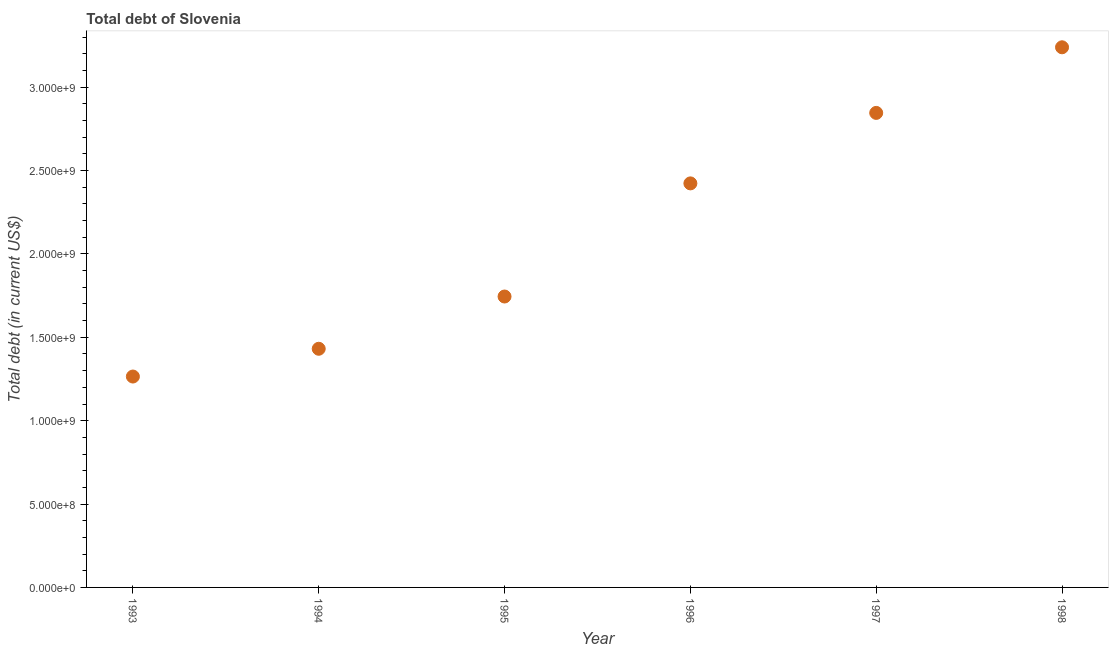What is the total debt in 1995?
Provide a succinct answer. 1.74e+09. Across all years, what is the maximum total debt?
Your response must be concise. 3.24e+09. Across all years, what is the minimum total debt?
Your answer should be compact. 1.26e+09. In which year was the total debt maximum?
Your response must be concise. 1998. In which year was the total debt minimum?
Give a very brief answer. 1993. What is the sum of the total debt?
Keep it short and to the point. 1.29e+1. What is the difference between the total debt in 1997 and 1998?
Make the answer very short. -3.94e+08. What is the average total debt per year?
Ensure brevity in your answer.  2.16e+09. What is the median total debt?
Keep it short and to the point. 2.08e+09. In how many years, is the total debt greater than 1100000000 US$?
Your response must be concise. 6. Do a majority of the years between 1997 and 1995 (inclusive) have total debt greater than 500000000 US$?
Your answer should be compact. No. What is the ratio of the total debt in 1996 to that in 1997?
Your response must be concise. 0.85. Is the total debt in 1993 less than that in 1997?
Your response must be concise. Yes. What is the difference between the highest and the second highest total debt?
Ensure brevity in your answer.  3.94e+08. Is the sum of the total debt in 1993 and 1995 greater than the maximum total debt across all years?
Provide a succinct answer. No. What is the difference between the highest and the lowest total debt?
Provide a short and direct response. 1.97e+09. Does the total debt monotonically increase over the years?
Offer a very short reply. Yes. How many years are there in the graph?
Provide a succinct answer. 6. What is the difference between two consecutive major ticks on the Y-axis?
Your response must be concise. 5.00e+08. Are the values on the major ticks of Y-axis written in scientific E-notation?
Your answer should be very brief. Yes. Does the graph contain grids?
Keep it short and to the point. No. What is the title of the graph?
Keep it short and to the point. Total debt of Slovenia. What is the label or title of the X-axis?
Give a very brief answer. Year. What is the label or title of the Y-axis?
Provide a succinct answer. Total debt (in current US$). What is the Total debt (in current US$) in 1993?
Offer a terse response. 1.26e+09. What is the Total debt (in current US$) in 1994?
Make the answer very short. 1.43e+09. What is the Total debt (in current US$) in 1995?
Your response must be concise. 1.74e+09. What is the Total debt (in current US$) in 1996?
Your answer should be compact. 2.42e+09. What is the Total debt (in current US$) in 1997?
Your response must be concise. 2.85e+09. What is the Total debt (in current US$) in 1998?
Offer a terse response. 3.24e+09. What is the difference between the Total debt (in current US$) in 1993 and 1994?
Offer a terse response. -1.66e+08. What is the difference between the Total debt (in current US$) in 1993 and 1995?
Ensure brevity in your answer.  -4.80e+08. What is the difference between the Total debt (in current US$) in 1993 and 1996?
Give a very brief answer. -1.16e+09. What is the difference between the Total debt (in current US$) in 1993 and 1997?
Your answer should be compact. -1.58e+09. What is the difference between the Total debt (in current US$) in 1993 and 1998?
Offer a terse response. -1.97e+09. What is the difference between the Total debt (in current US$) in 1994 and 1995?
Make the answer very short. -3.13e+08. What is the difference between the Total debt (in current US$) in 1994 and 1996?
Your response must be concise. -9.92e+08. What is the difference between the Total debt (in current US$) in 1994 and 1997?
Offer a very short reply. -1.41e+09. What is the difference between the Total debt (in current US$) in 1994 and 1998?
Offer a very short reply. -1.81e+09. What is the difference between the Total debt (in current US$) in 1995 and 1996?
Your answer should be compact. -6.79e+08. What is the difference between the Total debt (in current US$) in 1995 and 1997?
Give a very brief answer. -1.10e+09. What is the difference between the Total debt (in current US$) in 1995 and 1998?
Ensure brevity in your answer.  -1.49e+09. What is the difference between the Total debt (in current US$) in 1996 and 1997?
Your answer should be compact. -4.23e+08. What is the difference between the Total debt (in current US$) in 1996 and 1998?
Offer a very short reply. -8.16e+08. What is the difference between the Total debt (in current US$) in 1997 and 1998?
Your answer should be very brief. -3.94e+08. What is the ratio of the Total debt (in current US$) in 1993 to that in 1994?
Offer a terse response. 0.88. What is the ratio of the Total debt (in current US$) in 1993 to that in 1995?
Provide a succinct answer. 0.72. What is the ratio of the Total debt (in current US$) in 1993 to that in 1996?
Give a very brief answer. 0.52. What is the ratio of the Total debt (in current US$) in 1993 to that in 1997?
Offer a very short reply. 0.44. What is the ratio of the Total debt (in current US$) in 1993 to that in 1998?
Make the answer very short. 0.39. What is the ratio of the Total debt (in current US$) in 1994 to that in 1995?
Provide a succinct answer. 0.82. What is the ratio of the Total debt (in current US$) in 1994 to that in 1996?
Offer a very short reply. 0.59. What is the ratio of the Total debt (in current US$) in 1994 to that in 1997?
Provide a short and direct response. 0.5. What is the ratio of the Total debt (in current US$) in 1994 to that in 1998?
Offer a terse response. 0.44. What is the ratio of the Total debt (in current US$) in 1995 to that in 1996?
Give a very brief answer. 0.72. What is the ratio of the Total debt (in current US$) in 1995 to that in 1997?
Your response must be concise. 0.61. What is the ratio of the Total debt (in current US$) in 1995 to that in 1998?
Your response must be concise. 0.54. What is the ratio of the Total debt (in current US$) in 1996 to that in 1997?
Your answer should be very brief. 0.85. What is the ratio of the Total debt (in current US$) in 1996 to that in 1998?
Your response must be concise. 0.75. What is the ratio of the Total debt (in current US$) in 1997 to that in 1998?
Offer a very short reply. 0.88. 